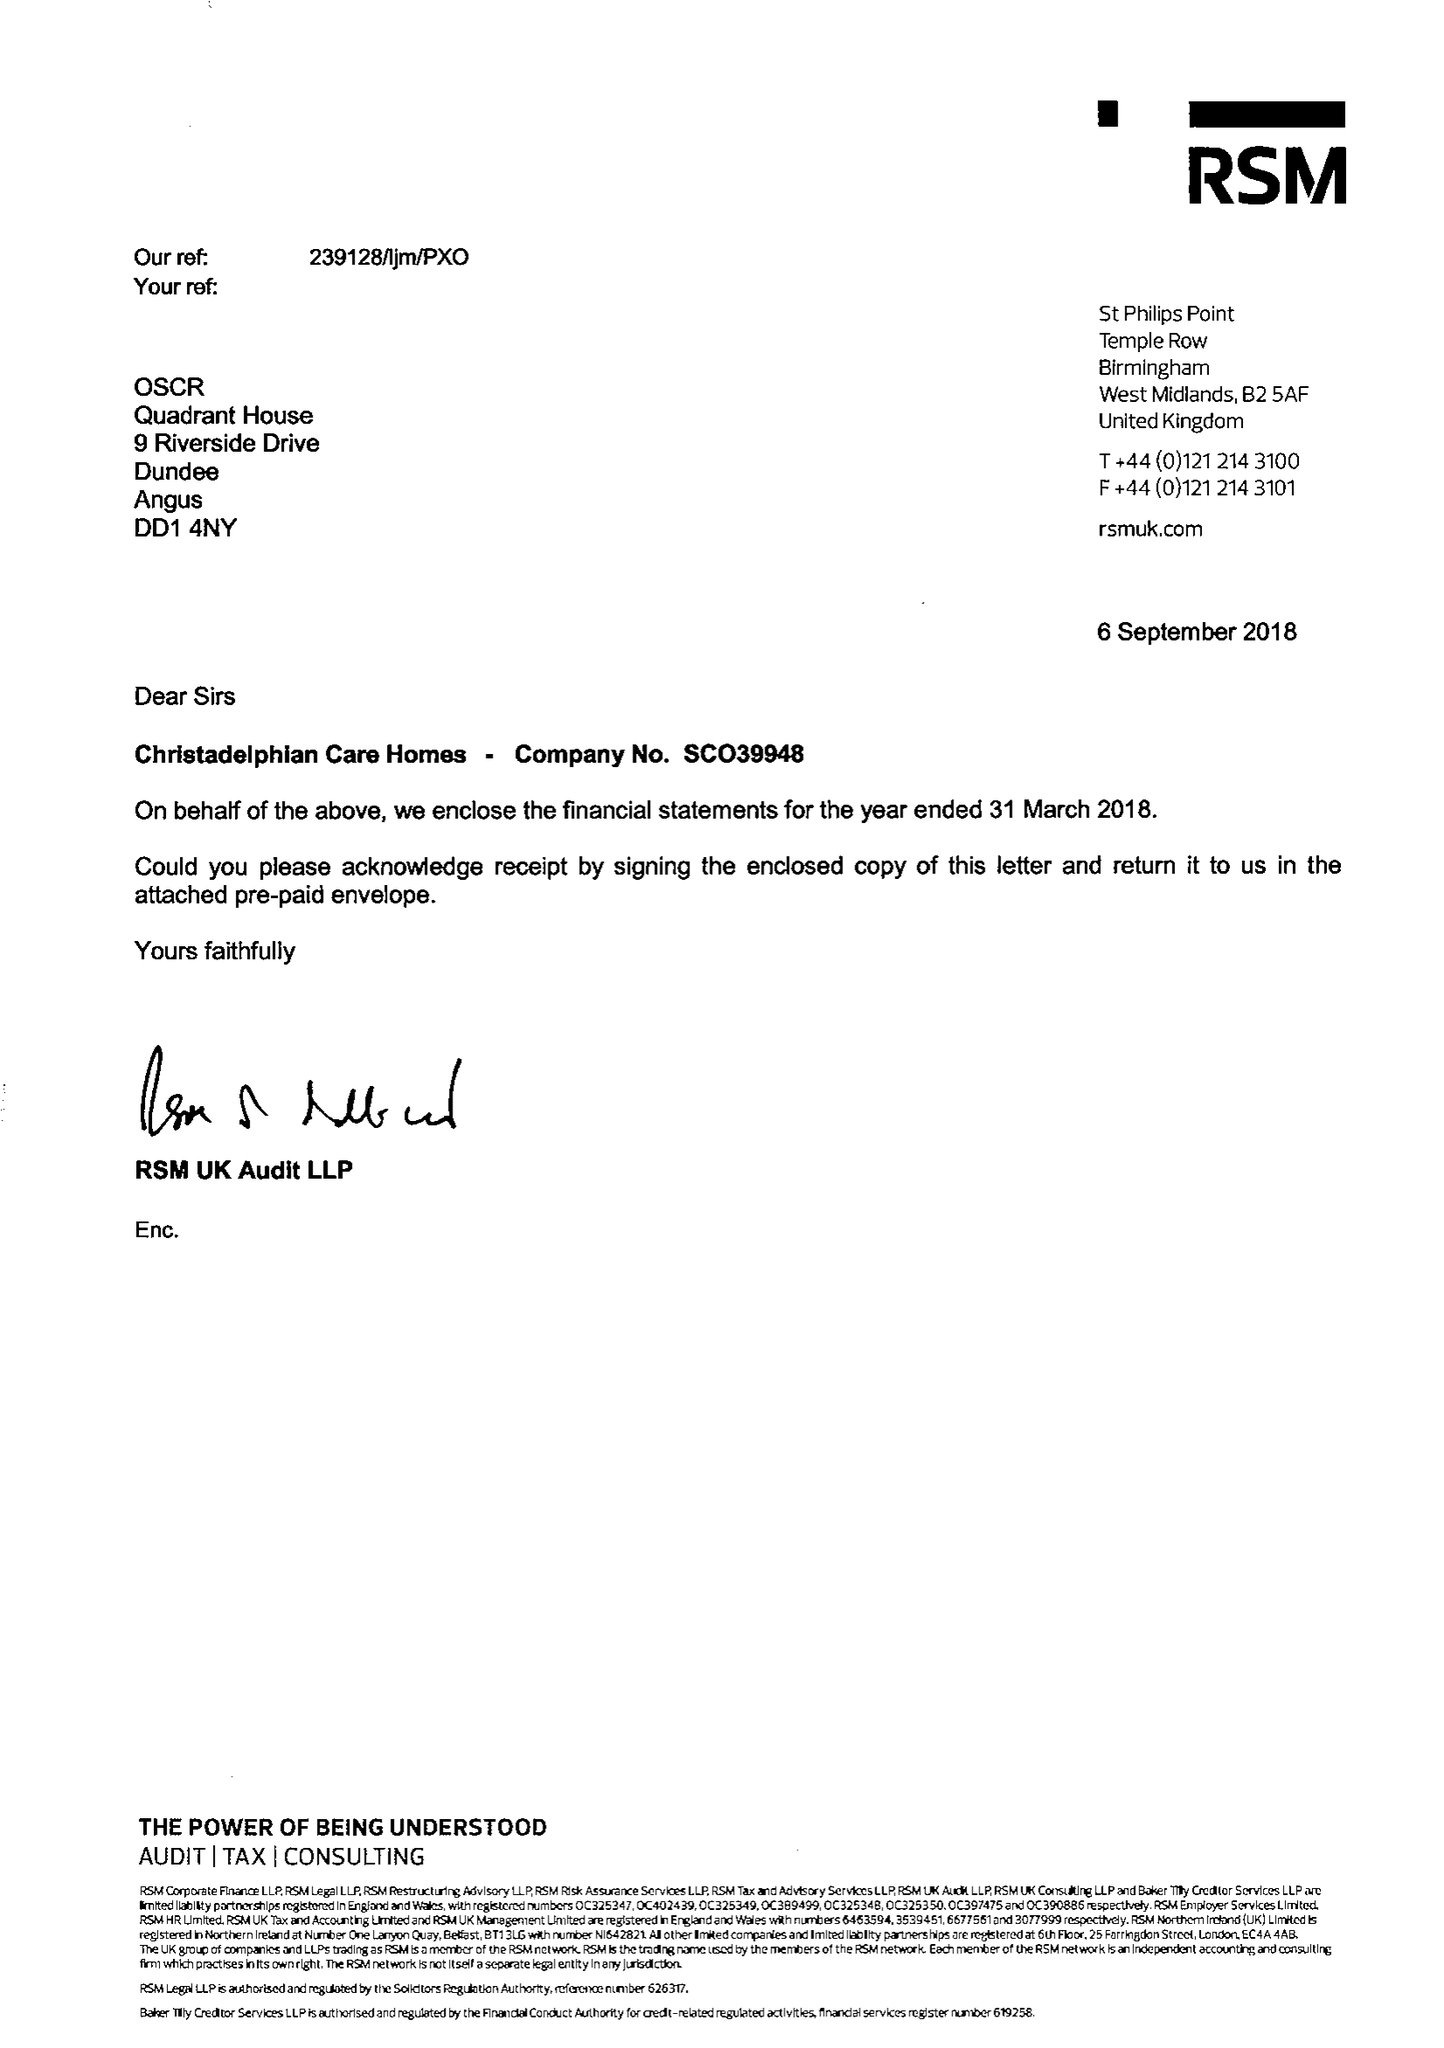What is the value for the charity_name?
Answer the question using a single word or phrase. Christadelphian Care Homes 